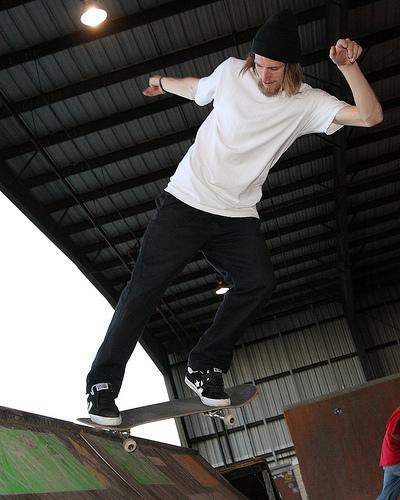Question: what color shirt is he wearing?
Choices:
A. Blue.
B. White.
C. Green.
D. Red.
Answer with the letter. Answer: B Question: why are his arms up?
Choices:
A. He is trying to balance.
B. He is being artistic.
C. He is trying to get attention.
D. He is waving.
Answer with the letter. Answer: A Question: what do his shoes look like?
Choices:
A. They are white and black.
B. They are white and green.
C. They are green and black.
D. They are yellow.
Answer with the letter. Answer: A 